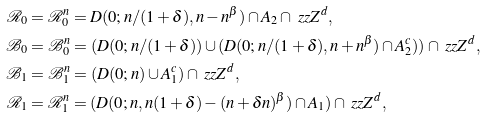Convert formula to latex. <formula><loc_0><loc_0><loc_500><loc_500>\mathcal { R } _ { 0 } & = \mathcal { R } _ { 0 } ^ { n } = D ( 0 ; n / ( 1 + \delta ) , n - n ^ { \beta } ) \cap A _ { 2 } \cap \ z z { Z } ^ { d } , \\ \mathcal { B } _ { 0 } & = \mathcal { B } _ { 0 } ^ { n } = ( D ( 0 ; n / ( 1 + \delta ) ) \cup ( D ( 0 ; n / ( 1 + \delta ) , n + n ^ { \beta } ) \cap A _ { 2 } ^ { c } ) ) \cap \ z z { Z } ^ { d } , \\ \mathcal { B } _ { 1 } & = \mathcal { B } _ { 1 } ^ { n } = ( D ( 0 ; n ) \cup A _ { 1 } ^ { c } ) \cap \ z z { Z } ^ { d } , \\ \mathcal { R } _ { 1 } & = \mathcal { R } _ { 1 } ^ { n } = ( D ( 0 ; n , n ( 1 + \delta ) - ( n + \delta n ) ^ { \beta } ) \cap A _ { 1 } ) \cap \ z z { Z } ^ { d } ,</formula> 